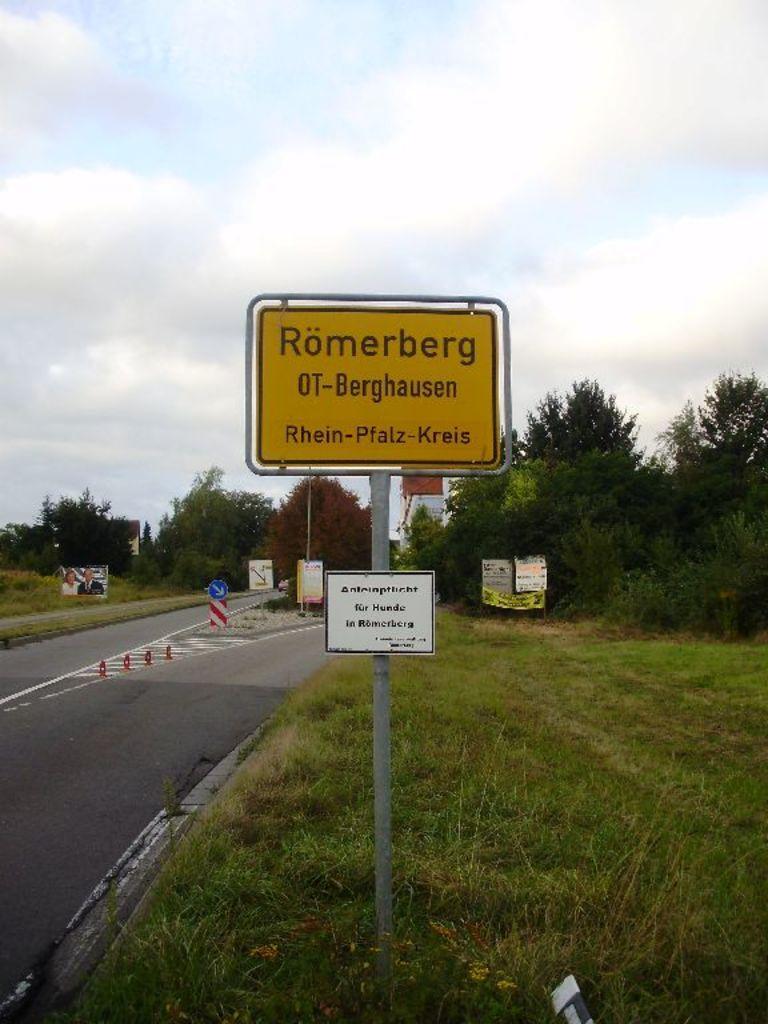Can you describe this image briefly? In this image we can see boards with some text, trees, grass, road and in the background we can see the sky. 